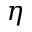Convert formula to latex. <formula><loc_0><loc_0><loc_500><loc_500>\eta</formula> 